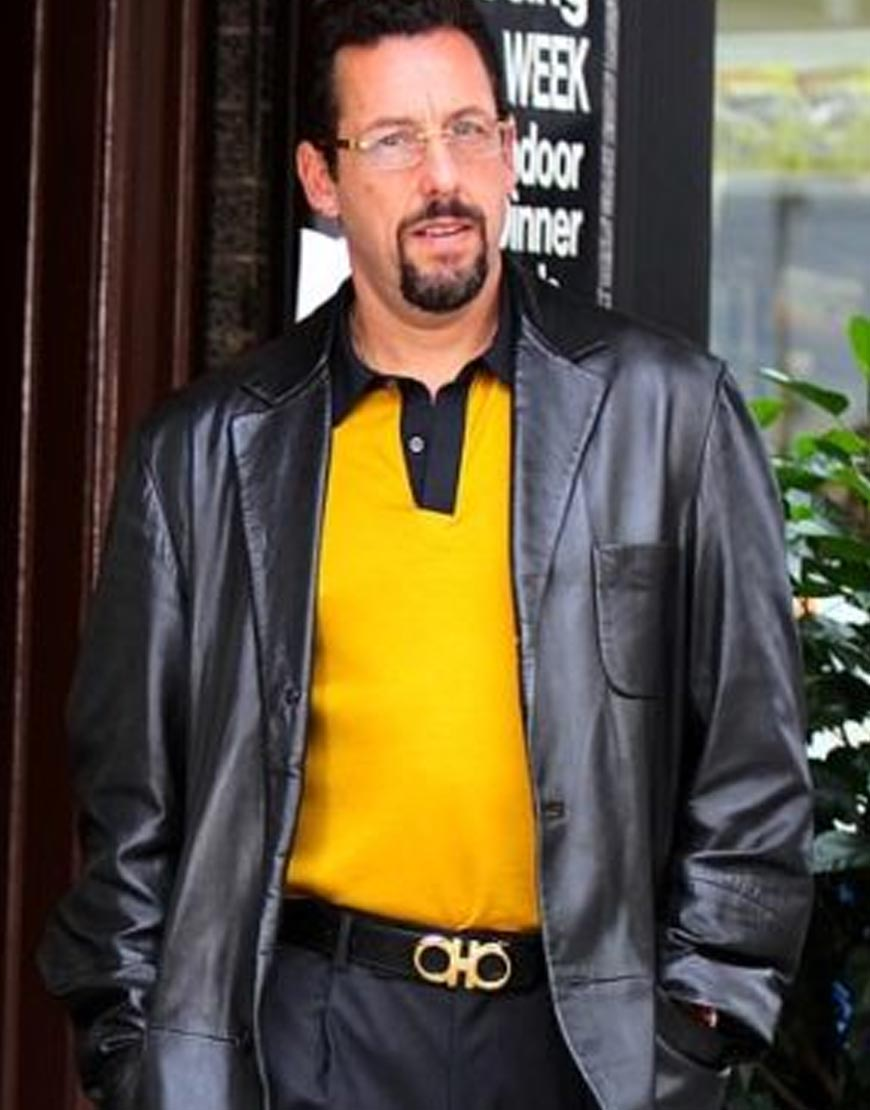What can be inferred about the setting based on the background and surroundings? The setting appears to be an urban environment, possibly a commercial or public area. The presence of a signboard in the background suggests that this location might be outside a store, restaurant, or another kind of business establishment. Additionally, the visible foliage indicates that this area is likely well-maintained and has some green elements, which is common in commercial or social gathering places in the city. Unfortunately, without more indicators, it is challenging to pinpoint the exact location. 